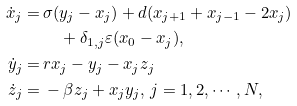Convert formula to latex. <formula><loc_0><loc_0><loc_500><loc_500>\dot { x } _ { j } = & \, \sigma ( y _ { j } - x _ { j } ) + d ( x _ { j + 1 } + x _ { j - 1 } - 2 x _ { j } ) \\ & \, \quad + \delta _ { 1 , j } \varepsilon ( x _ { 0 } - x _ { j } ) , \\ \dot { y } _ { j } = & \, r x _ { j } - y _ { j } - x _ { j } z _ { j } \\ \dot { z } _ { j } = & \, - \beta z _ { j } + x _ { j } y _ { j } , \, j = 1 , 2 , \cdots , N ,</formula> 